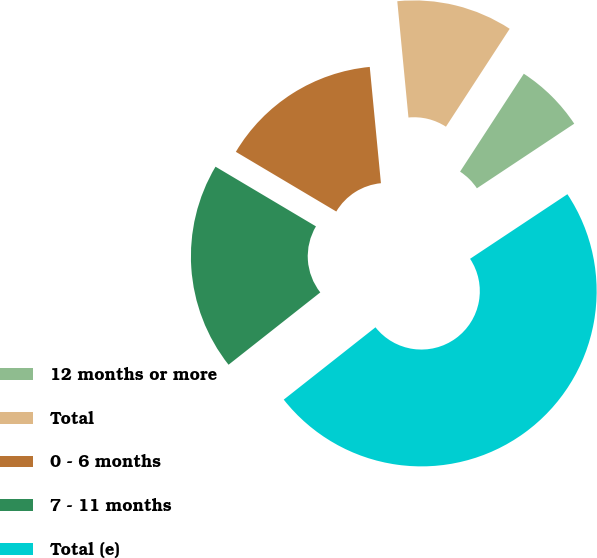Convert chart. <chart><loc_0><loc_0><loc_500><loc_500><pie_chart><fcel>12 months or more<fcel>Total<fcel>0 - 6 months<fcel>7 - 11 months<fcel>Total (e)<nl><fcel>6.49%<fcel>10.71%<fcel>14.94%<fcel>19.16%<fcel>48.7%<nl></chart> 